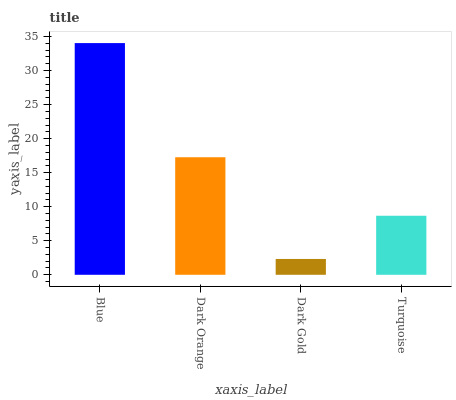Is Dark Gold the minimum?
Answer yes or no. Yes. Is Blue the maximum?
Answer yes or no. Yes. Is Dark Orange the minimum?
Answer yes or no. No. Is Dark Orange the maximum?
Answer yes or no. No. Is Blue greater than Dark Orange?
Answer yes or no. Yes. Is Dark Orange less than Blue?
Answer yes or no. Yes. Is Dark Orange greater than Blue?
Answer yes or no. No. Is Blue less than Dark Orange?
Answer yes or no. No. Is Dark Orange the high median?
Answer yes or no. Yes. Is Turquoise the low median?
Answer yes or no. Yes. Is Turquoise the high median?
Answer yes or no. No. Is Blue the low median?
Answer yes or no. No. 